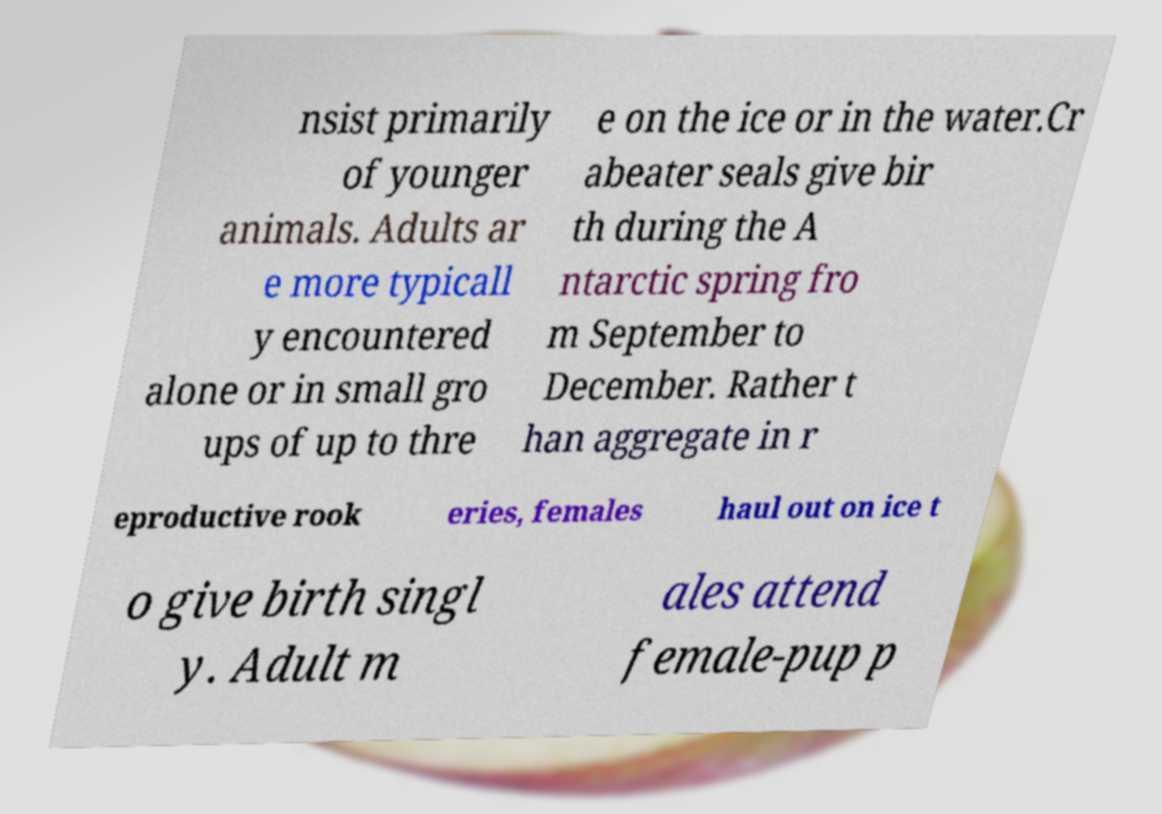For documentation purposes, I need the text within this image transcribed. Could you provide that? nsist primarily of younger animals. Adults ar e more typicall y encountered alone or in small gro ups of up to thre e on the ice or in the water.Cr abeater seals give bir th during the A ntarctic spring fro m September to December. Rather t han aggregate in r eproductive rook eries, females haul out on ice t o give birth singl y. Adult m ales attend female-pup p 